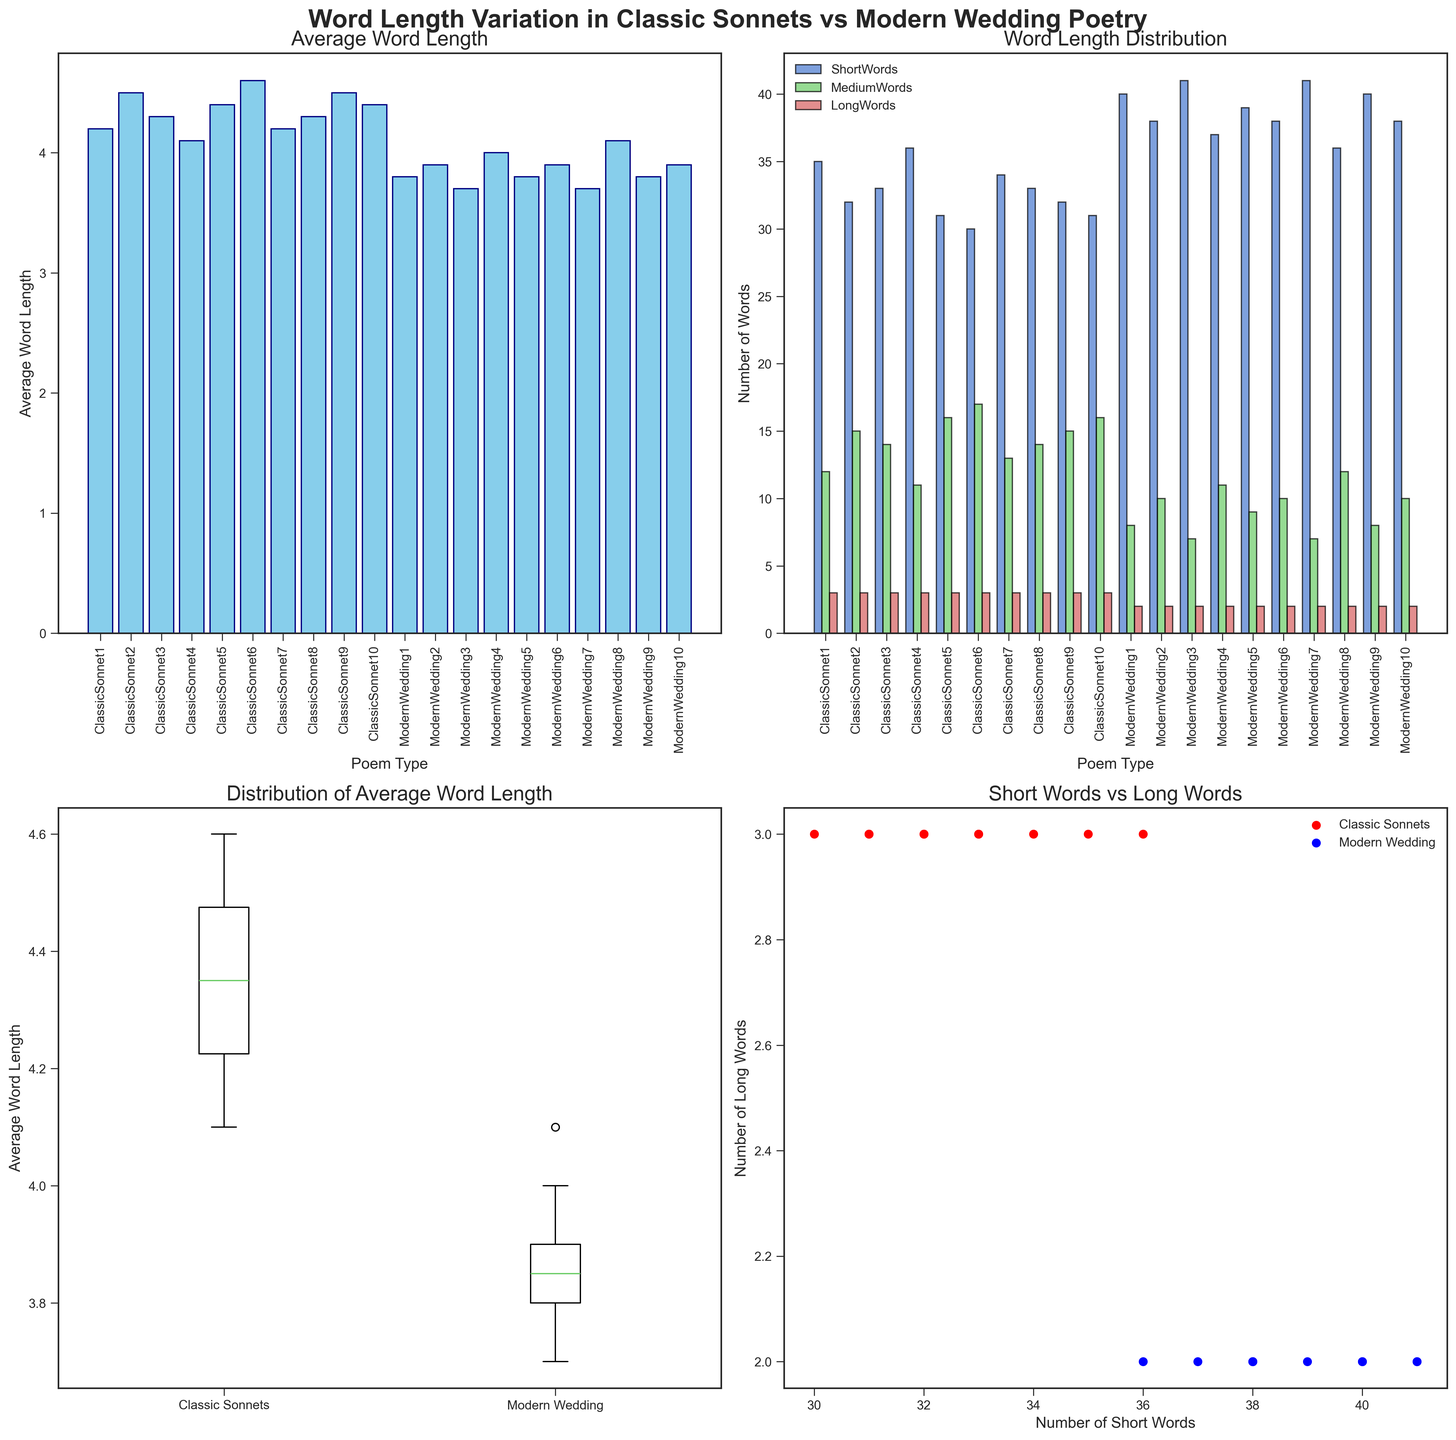What's the average word length in Modern Wedding poem 4? Refer to the "Average Word Length" subplot, locate the bar labeled "ModernWedding4" and read its height. The height of this bar represents the average word length for Modern Wedding poem 4.
Answer: 4.0 What is the total count of short and medium words in Classic Sonnet 5? Refer to the "Word Length Distribution" subplot. For "ClassicSonnet5", add the height of the bar representing short words to the height of the bar representing medium words (31 + 16).
Answer: 47 Which type of poem tends to have a shorter average word length: Classic Sonnets or Modern Wedding poems? Check the "Distribution of Average Word Length" boxplot. The median line in the box for Modern Wedding poems is lower than that for Classic Sonnets, indicating shorter average word length.
Answer: Modern Wedding poems Are there any outliers in the average word length of Classic Sonnets? Look at the "Distribution of Average Word Length" boxplot. There are no points that fall outside the whiskers for Classic Sonnets, indicating no outliers.
Answer: No How do the counts of short and long words correlate in Modern Wedding poems? Refer to the "Short Words vs Long Words" scatter plot. Modern Wedding poems are represented by blue dots, and most dots show a trend where higher counts of short words generally have similar counts of long words (mostly around 2 long words).
Answer: Weak positive correlation What is the difference between the highest and lowest average word lengths in Classic Sonnets? Refer to the "Average Word Length" subplot. The highest bar for Classic Sonnets is 4.6 and the lowest is 4.1. Subtract the lowest from the highest (4.6 - 4.1).
Answer: 0.5 Which poem type has a wider range of average word lengths? Compare the lengths of the whiskers in the "Distribution of Average Word Length" boxplot for both Classic Sonnets and Modern Wedding poems. The whiskers of Modern Wedding poems are longer than those of Classic Sonnets, indicating a wider range.
Answer: Modern Wedding poems Do more Modern Wedding poems have a higher count of short words compared to Classic Sonnets? Refer to the "Word Length Distribution" subplot. The bars for short words in Modern Wedding poems are generally taller compared to those for Classic Sonnets.
Answer: Yes Which has more medium-length words on average: Classic Sonnets or Modern Wedding poems? Refer to the "Word Length Distribution" subplot. The bars for medium-length words for Classic Sonnets on average are taller than those for Modern Wedding poems.
Answer: Classic Sonnets Is there any difference in the number of long words between Classic Sonnets and Modern Wedding poems? Refer to the "Word Length Distribution" subplot. Both Classic Sonnets and Modern Wedding poems have similar bar heights for long words, typically showing 3 for Classic Sonnets and 2 for Modern Wedding poems.
Answer: Yes 